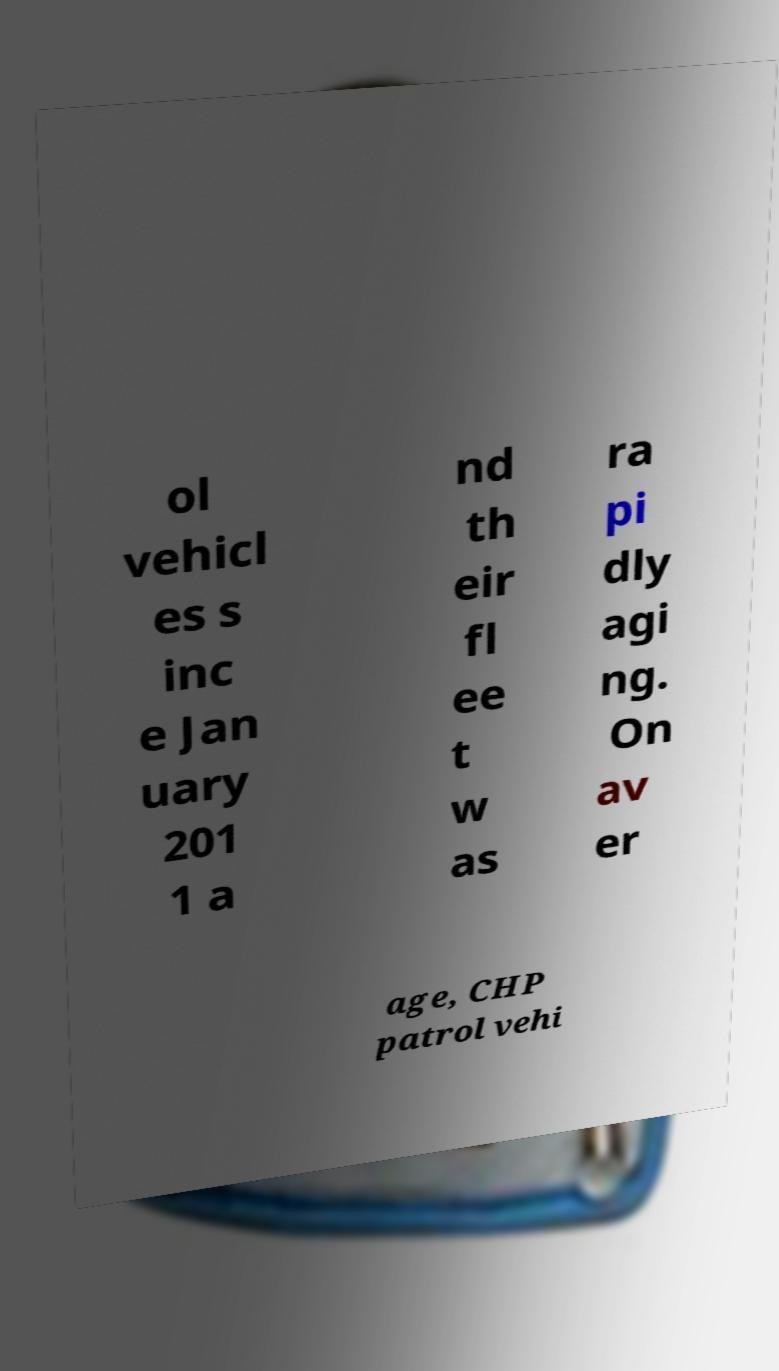I need the written content from this picture converted into text. Can you do that? ol vehicl es s inc e Jan uary 201 1 a nd th eir fl ee t w as ra pi dly agi ng. On av er age, CHP patrol vehi 